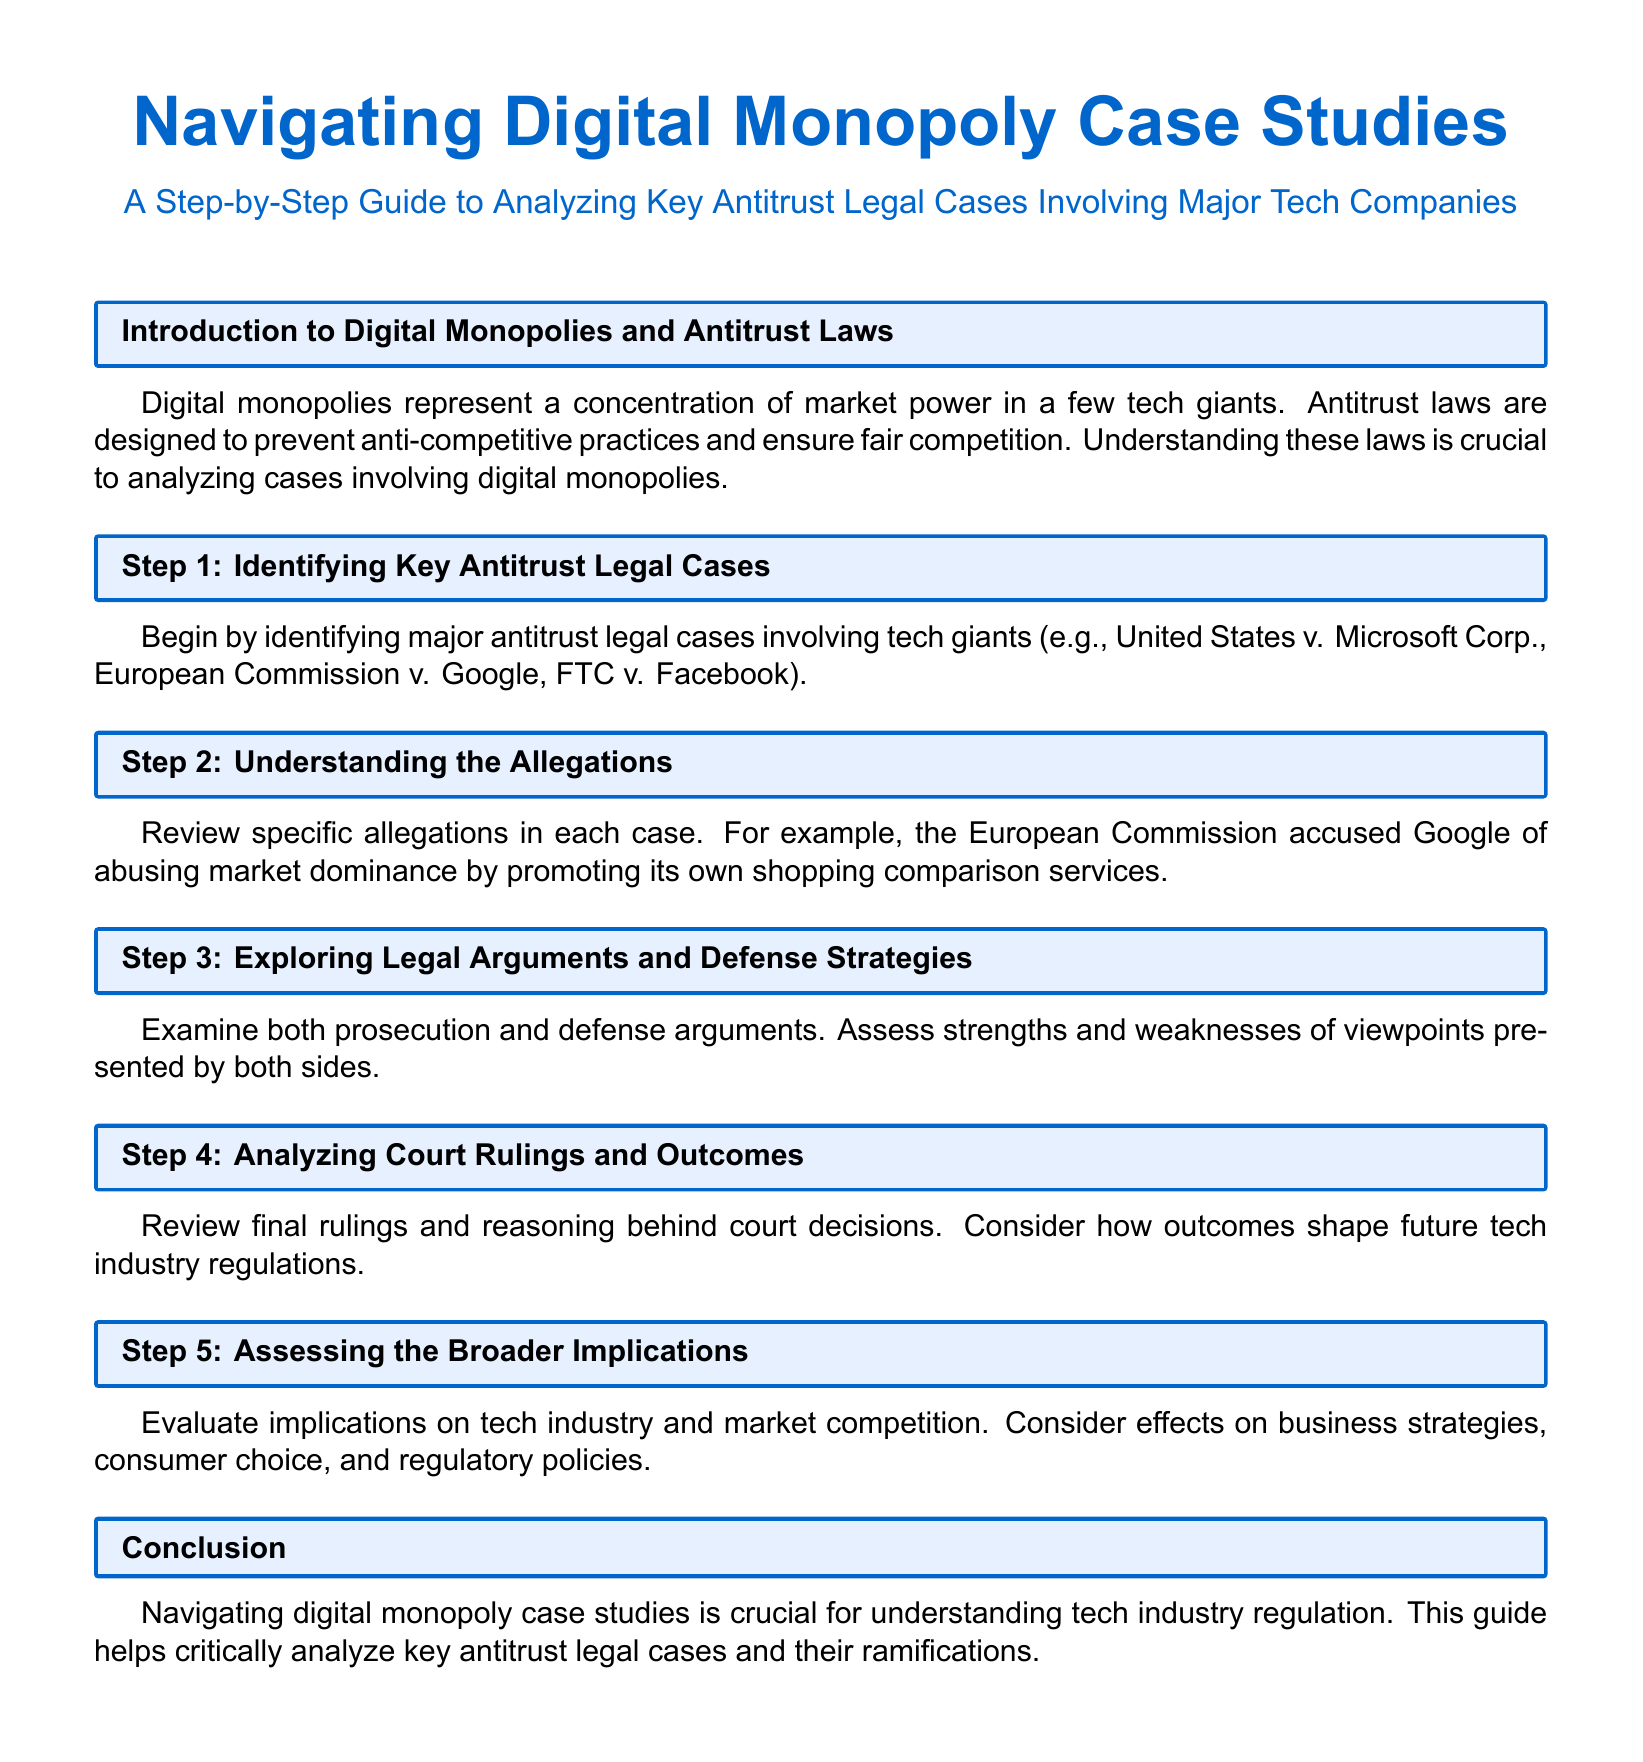What is the main focus of the guide? The guide focuses on analyzing antitrust legal cases involving major tech companies and the implications of digital monopolies.
Answer: Analyzing antitrust legal cases What is the first step in the guide? The first step involves identifying major antitrust legal cases involving tech giants.
Answer: Identifying key antitrust legal cases Which company was accused by the European Commission of abusing market dominance? The document specifically mentions Google as being accused of abusing market dominance.
Answer: Google What is the final step outlined in the guide? The final step involves assessing the broader implications on the tech industry and market competition.
Answer: Assessing the broader implications What are antitrust laws designed to prevent? Antitrust laws are designed to prevent anti-competitive practices and ensure fair competition.
Answer: Anti-competitive practices What is a key case mentioned in the guide involving Microsoft? The guide refers to United States v. Microsoft Corp. as a key antitrust case.
Answer: United States v. Microsoft Corp What does the conclusion of the guide emphasize? The conclusion emphasizes the importance of understanding tech industry regulation through the analysis of antitrust cases.
Answer: Understanding tech industry regulation How does the guide suggest evaluating implications? The guide suggests evaluating implications by considering effects on business strategies, consumer choice, and regulatory policies.
Answer: Through effects on business strategies, consumer choice, and regulatory policies 